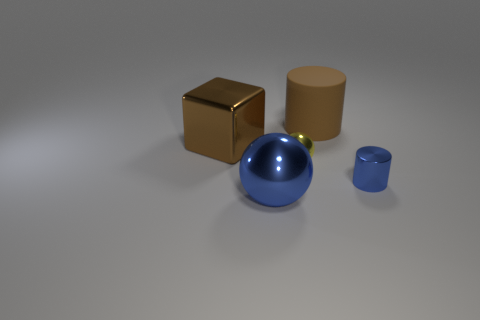There is a metallic cube that is the same color as the large cylinder; what size is it?
Give a very brief answer. Large. There is a metal cube; is its color the same as the cylinder that is on the left side of the tiny blue shiny cylinder?
Ensure brevity in your answer.  Yes. What shape is the thing that is the same color as the big block?
Make the answer very short. Cylinder. Is there anything else that is the same material as the large brown cylinder?
Keep it short and to the point. No. Is the material of the big blue object the same as the large cylinder?
Keep it short and to the point. No. The large brown object that is left of the big brown thing behind the brown thing in front of the brown rubber object is what shape?
Provide a short and direct response. Cube. Are there fewer big blue metal things in front of the small blue metal cylinder than blue cylinders to the left of the large rubber object?
Make the answer very short. No. There is a brown object that is in front of the object behind the metal block; what is its shape?
Your response must be concise. Cube. Are there any other things that have the same color as the tiny cylinder?
Ensure brevity in your answer.  Yes. Is the tiny shiny sphere the same color as the small cylinder?
Your answer should be compact. No. 